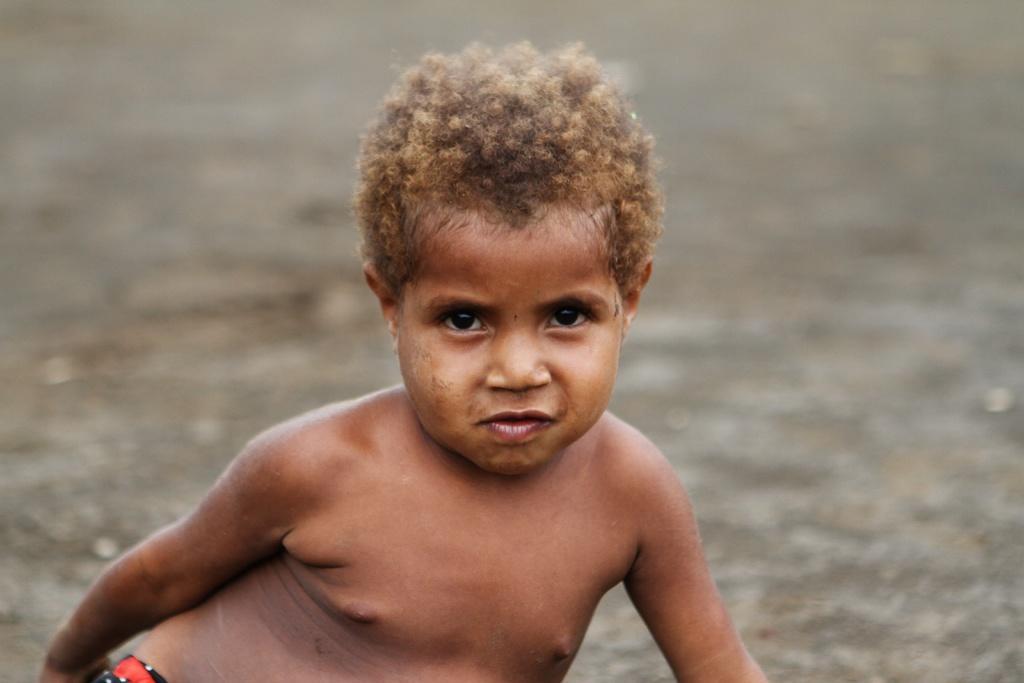Can you describe this image briefly? In this image, in the middle, we can see a kid. In the background, we can see white color. 